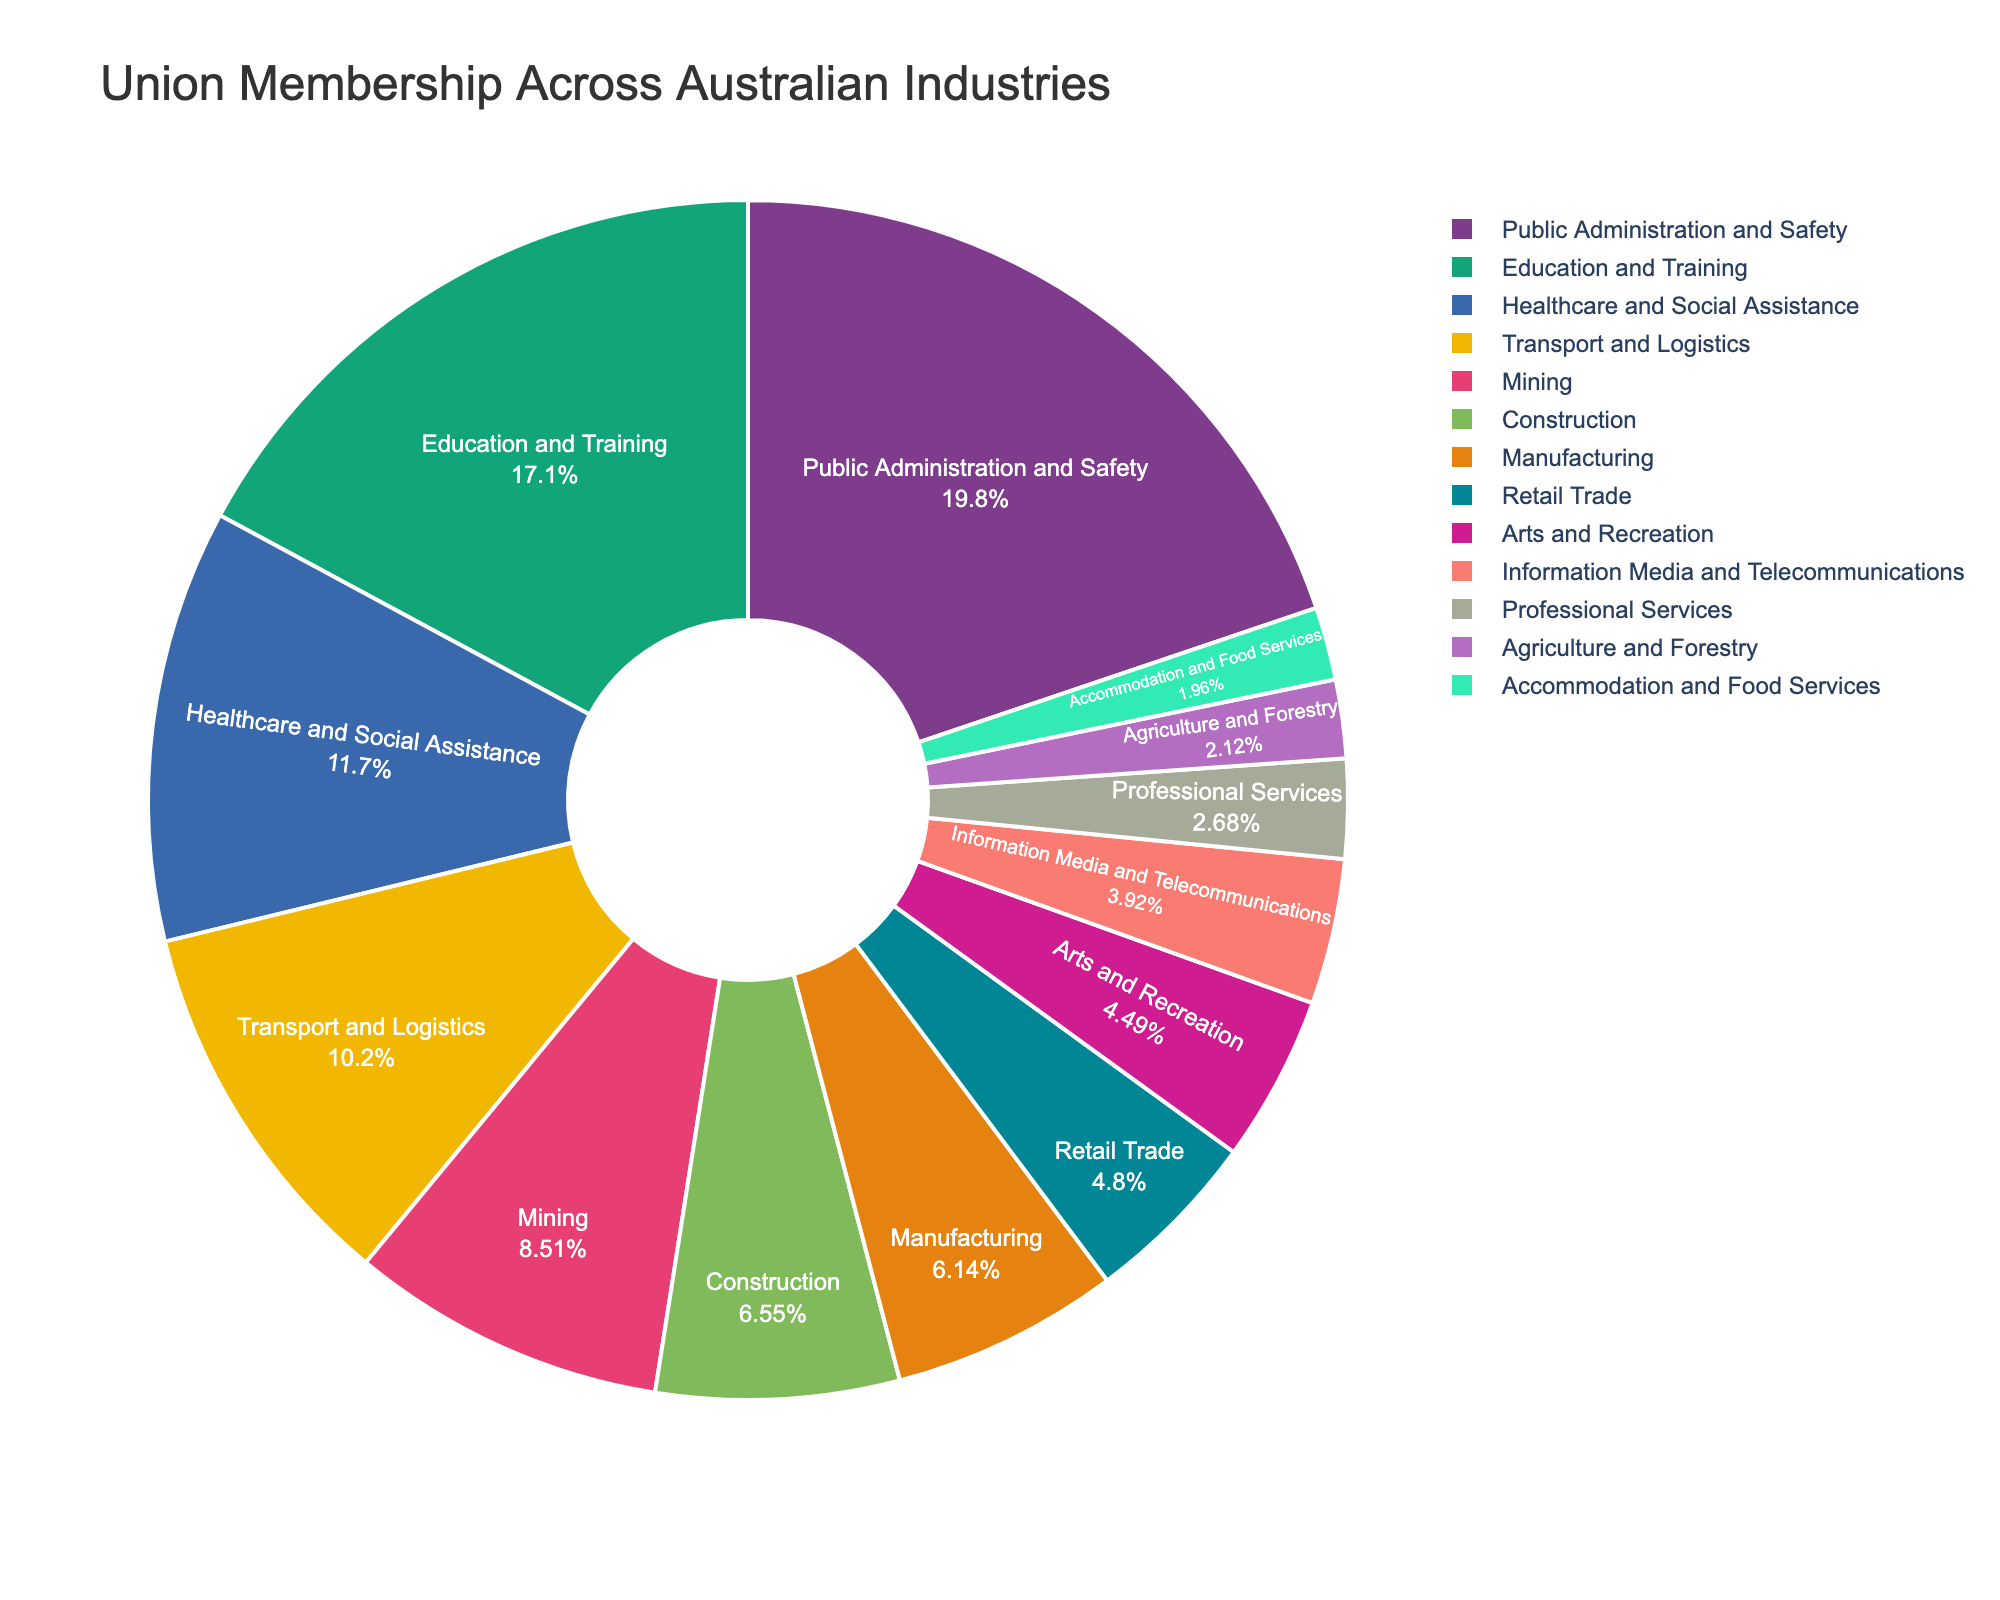What industry has the highest union membership percentage? By looking at the pie chart, identify the industry segment with the largest proportion.
Answer: Public Administration and Safety Which industry has a higher union membership percentage: Mining or Agriculture and Forestry? Compare the percentage values of Mining and Agriculture and Forestry shown in the chart.
Answer: Mining Which industry has the lowest union membership percentage? By inspecting the pie chart, find the industry segment with the smallest proportion.
Answer: Accommodation and Food Services What is the combined percentage of union membership for Education and Training and Healthcare and Social Assistance? Add the percentage values of Education and Training (33.2%) and Healthcare and Social Assistance (22.6%).  33.2 + 22.6 = 55.8
Answer: 55.8% Is the union membership percentage in Transport and Logistics greater than in Manufacturing? Compare the segment representing Transport and Logistics with the one for Manufacturing. Transport and Logistics has 19.8%, which is greater than Manufacturing’s 11.9%.
Answer: Yes Which industries have a union membership percentage below 10%? Identify all segments with membership percentages less than 10% by viewing the pie chart. These are Retail Trade (9.3%), Professional Services (5.2%), Accommodation and Food Services (3.8%), Arts and Recreation (8.7%), Agriculture and Forestry (4.1%), and Information Media and Telecommunications (7.6%).
Answer: Retail Trade, Professional Services, Accommodation and Food Services, Arts and Recreation, Agriculture and Forestry, Information Media and Telecommunications How much greater is the union membership percentage in Public Administration and Safety compared to that in Manufacturing? Subtract the percentage value of Manufacturing from Public Administration and Safety. 38.4% - 11.9% = 26.5%
Answer: 26.5% What is the average union membership percentage across the Construction, Manufacturing, and Education and Training industries? Sum the percentage values of Construction (12.7%), Manufacturing (11.9%), and Education and Training (33.2%), then divide by 3. (12.7 + 11.9 + 33.2) / 3 = 19.27
Answer: 19.27 Is the union membership in Healthcare and Social Assistance closer to Retail Trade or Mining? Compare the difference between Healthcare and Social Assistance (22.6%) and both Retail Trade (9.3%) and Mining (16.5%). The difference between Healthcare and Social Assistance and Retail Trade is 22.6 - 9.3 = 13.3%, and the difference between Healthcare and Social Assistance and Mining is 22.6 - 16.5 = 6.1%. Since 6.1% is smaller than 13.3%, Healthcare and Social Assistance is closer to Mining.
Answer: Mining 